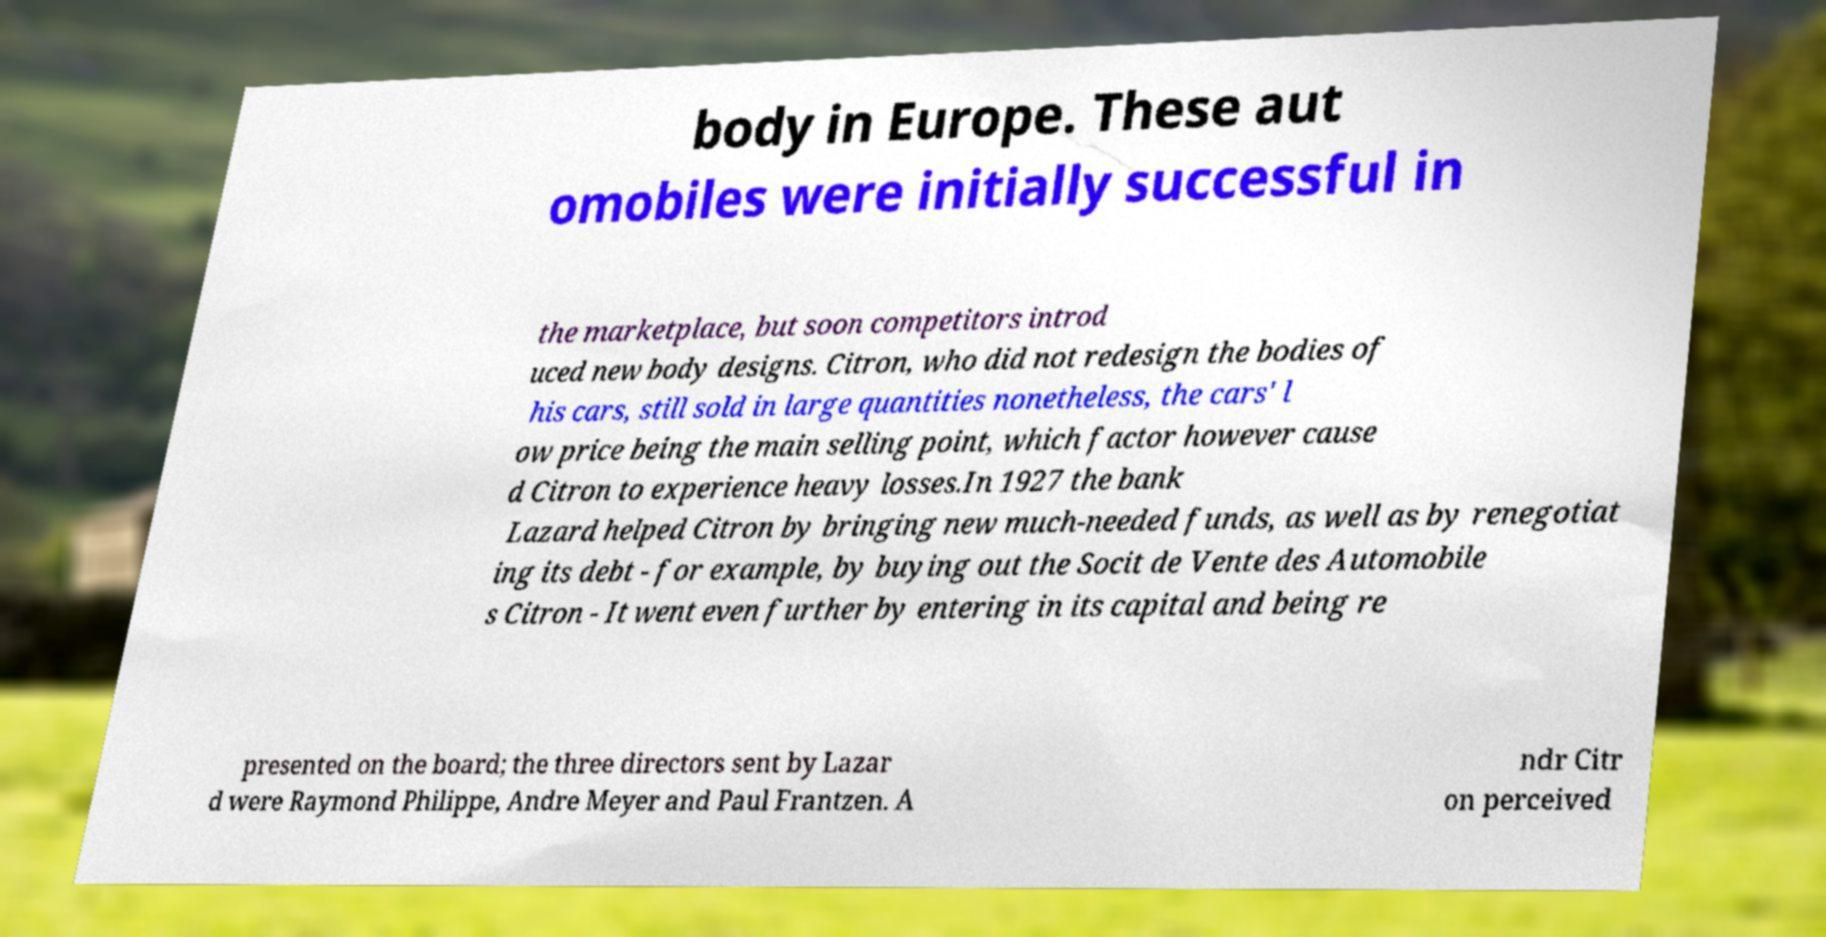Could you assist in decoding the text presented in this image and type it out clearly? body in Europe. These aut omobiles were initially successful in the marketplace, but soon competitors introd uced new body designs. Citron, who did not redesign the bodies of his cars, still sold in large quantities nonetheless, the cars' l ow price being the main selling point, which factor however cause d Citron to experience heavy losses.In 1927 the bank Lazard helped Citron by bringing new much-needed funds, as well as by renegotiat ing its debt - for example, by buying out the Socit de Vente des Automobile s Citron - It went even further by entering in its capital and being re presented on the board; the three directors sent by Lazar d were Raymond Philippe, Andre Meyer and Paul Frantzen. A ndr Citr on perceived 